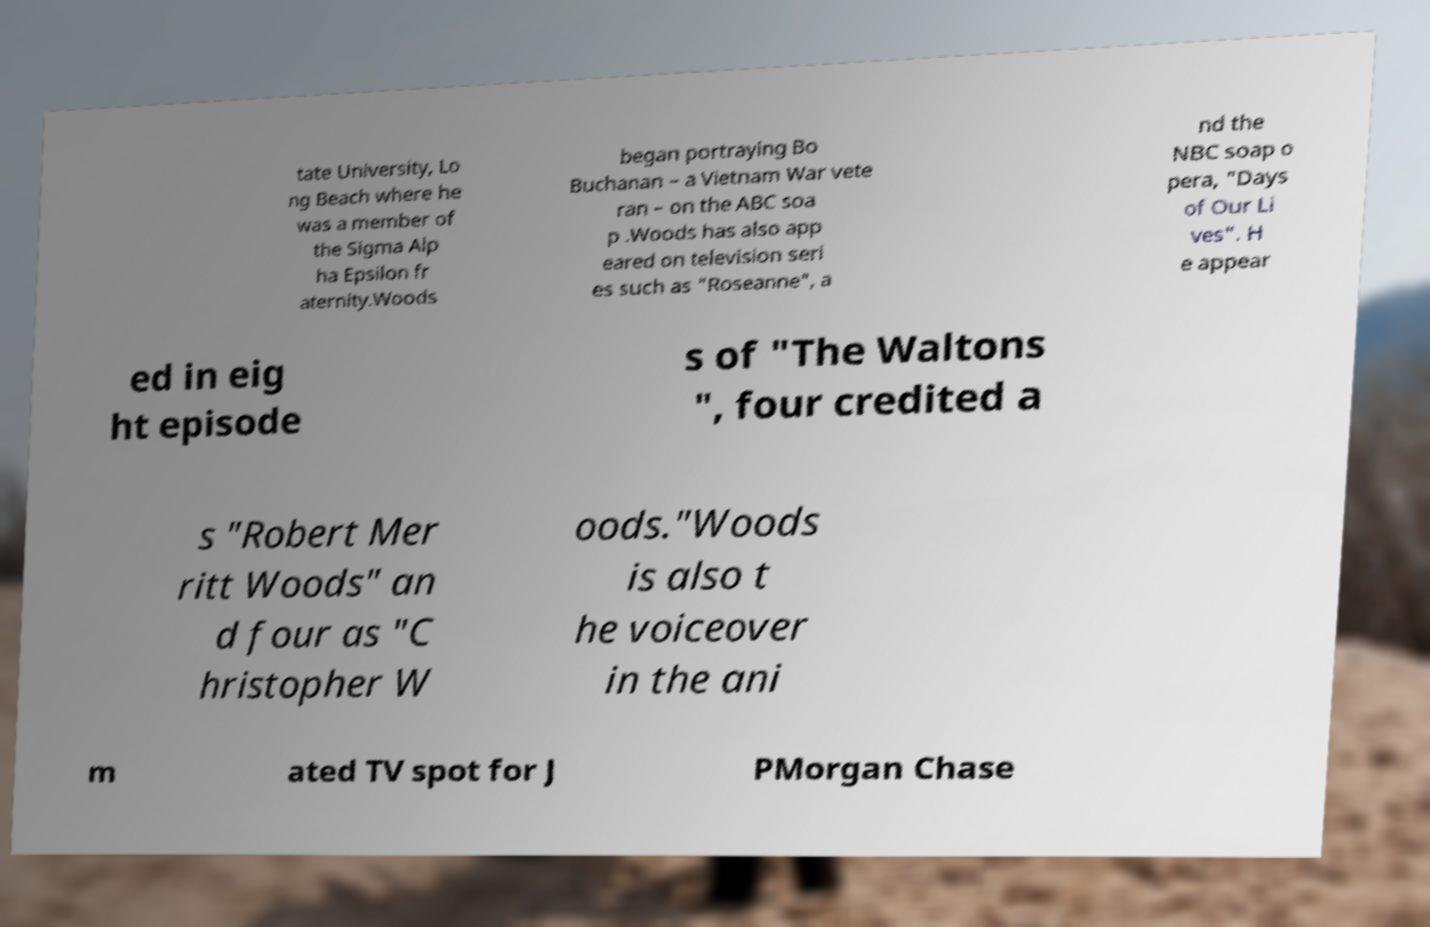There's text embedded in this image that I need extracted. Can you transcribe it verbatim? tate University, Lo ng Beach where he was a member of the Sigma Alp ha Epsilon fr aternity.Woods began portraying Bo Buchanan – a Vietnam War vete ran – on the ABC soa p .Woods has also app eared on television seri es such as "Roseanne", a nd the NBC soap o pera, "Days of Our Li ves". H e appear ed in eig ht episode s of "The Waltons ", four credited a s "Robert Mer ritt Woods" an d four as "C hristopher W oods."Woods is also t he voiceover in the ani m ated TV spot for J PMorgan Chase 